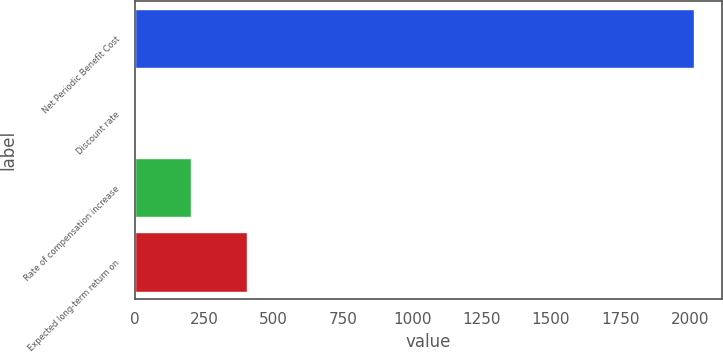<chart> <loc_0><loc_0><loc_500><loc_500><bar_chart><fcel>Net Periodic Benefit Cost<fcel>Discount rate<fcel>Rate of compensation increase<fcel>Expected long-term return on<nl><fcel>2017<fcel>1.03<fcel>202.63<fcel>404.23<nl></chart> 